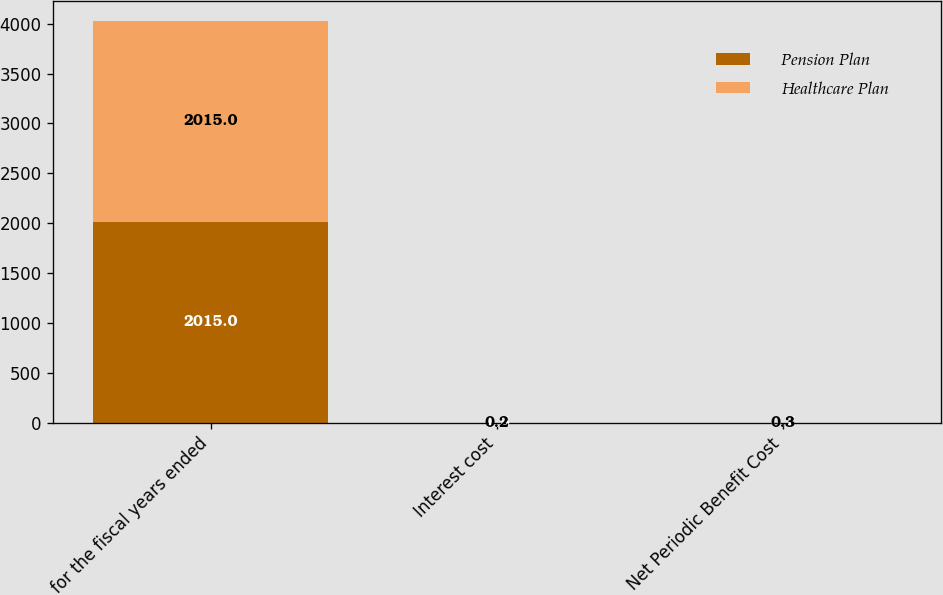<chart> <loc_0><loc_0><loc_500><loc_500><stacked_bar_chart><ecel><fcel>for the fiscal years ended<fcel>Interest cost<fcel>Net Periodic Benefit Cost<nl><fcel>Pension Plan<fcel>2015<fcel>1.5<fcel>0.7<nl><fcel>Healthcare Plan<fcel>2015<fcel>0.2<fcel>0.3<nl></chart> 